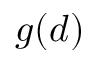Convert formula to latex. <formula><loc_0><loc_0><loc_500><loc_500>g ( d )</formula> 